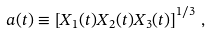<formula> <loc_0><loc_0><loc_500><loc_500>a ( t ) \equiv \left [ X _ { 1 } ( t ) X _ { 2 } ( t ) X _ { 3 } ( t ) \right ] ^ { 1 / 3 } \, ,</formula> 